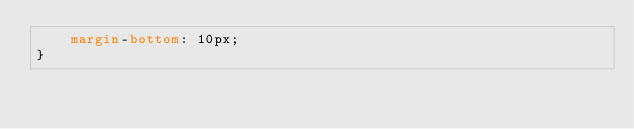Convert code to text. <code><loc_0><loc_0><loc_500><loc_500><_CSS_>    margin-bottom: 10px;
}</code> 